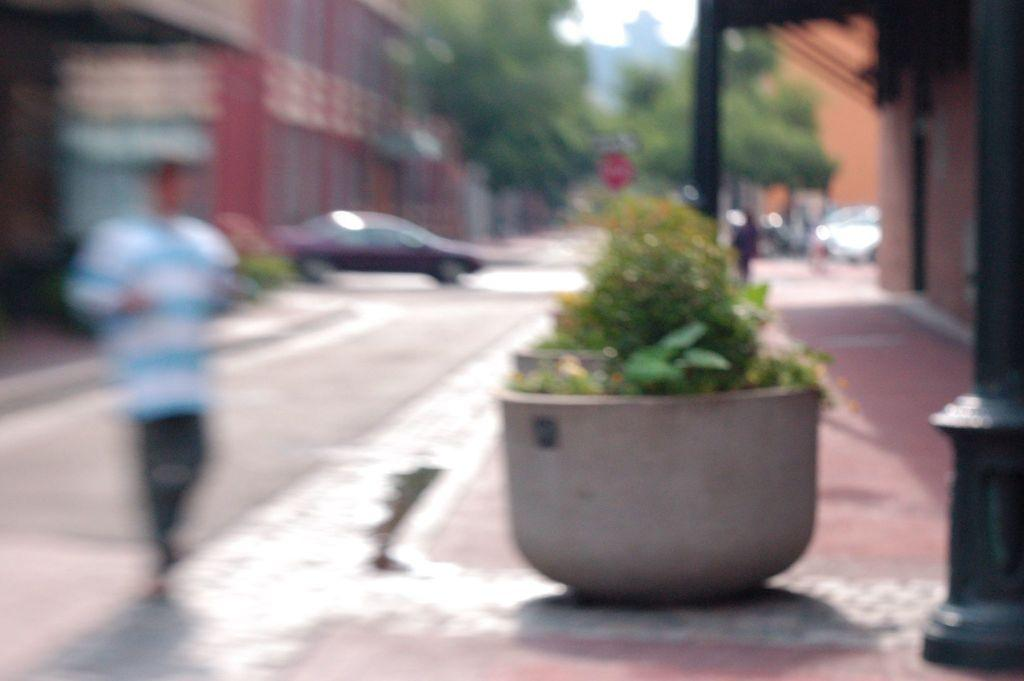What is in the pot that is visible in the image? There is a pot with plants in the image. Who or what is present in the image besides the pot? There is a person, a road, a car, buildings, and trees visible in the image. What type of transportation can be seen in the image? There is a car in the image. What type of structures are present in the image? There are buildings in the image. What type of oranges are being sold at the insurance office in the image? There is no mention of oranges or an insurance office in the image. 